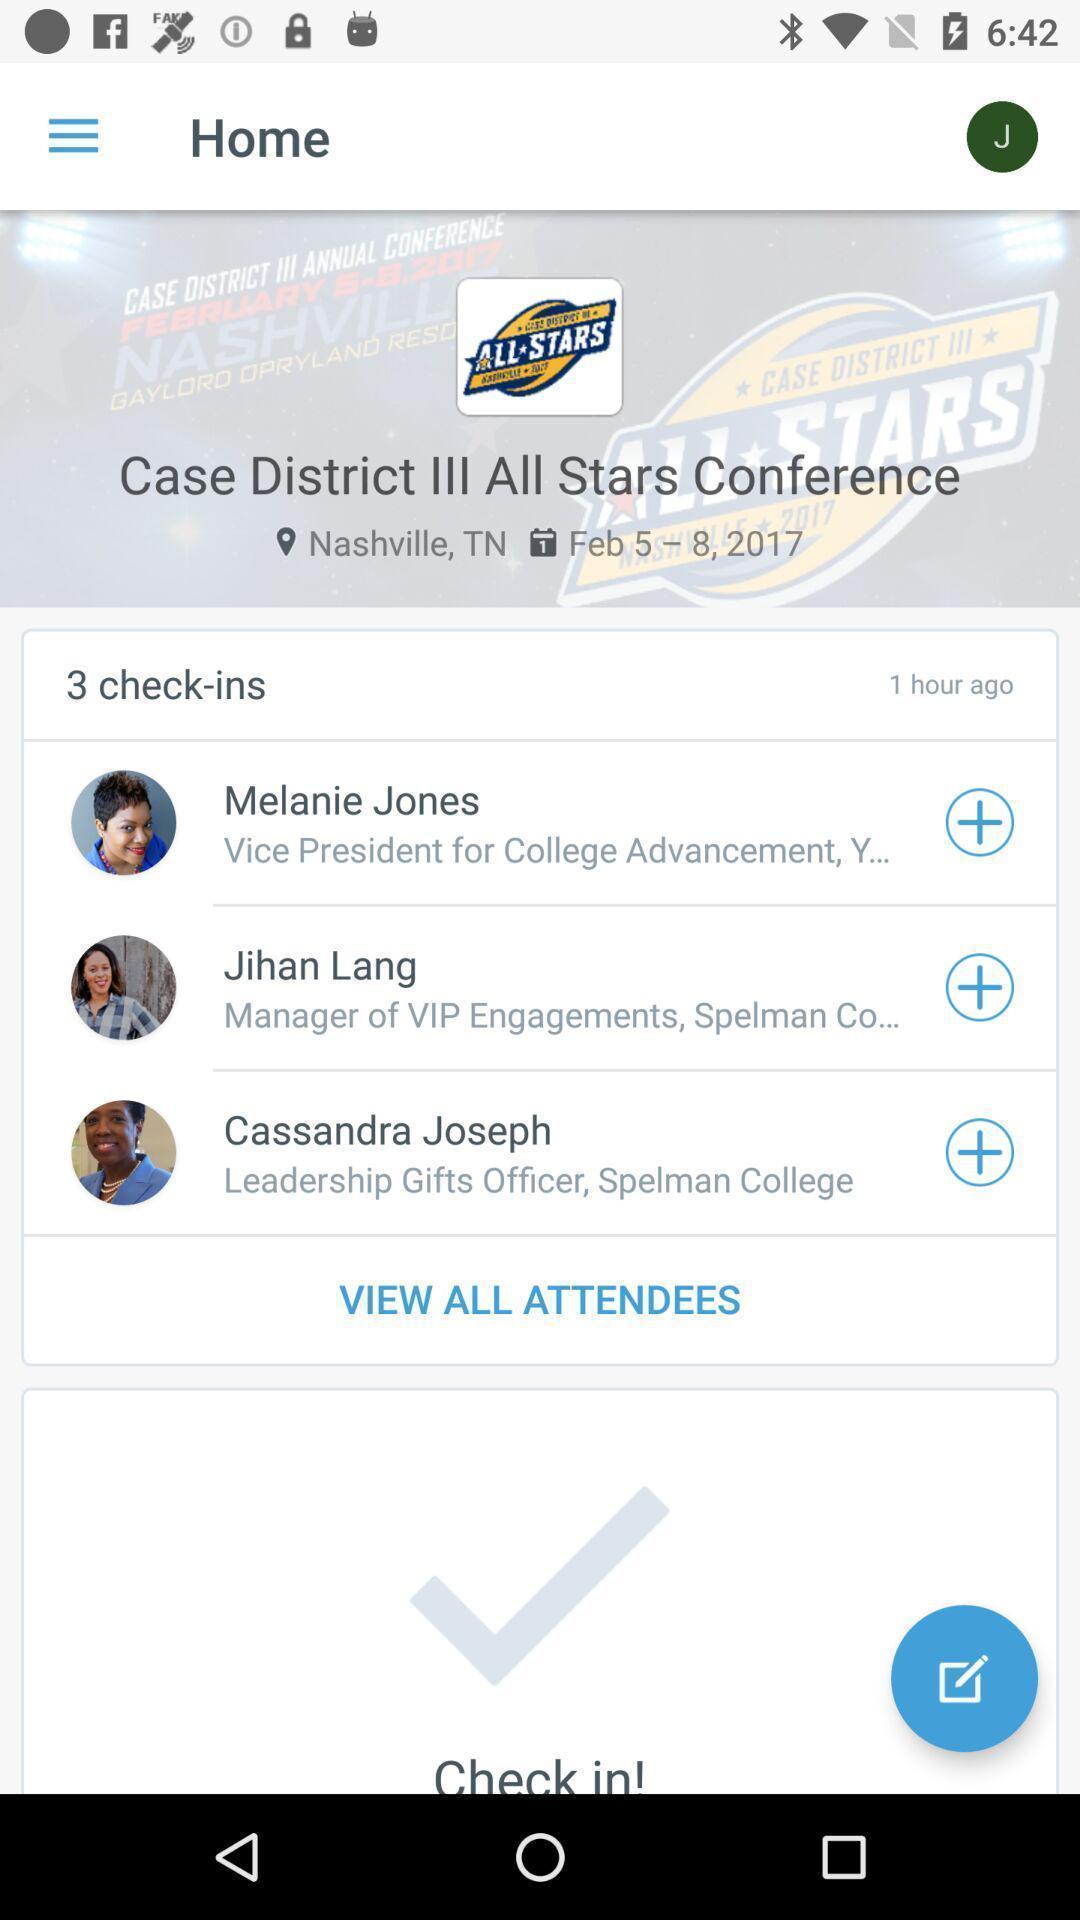Tell me about the visual elements in this screen capture. Page displaying the list of attendees. 